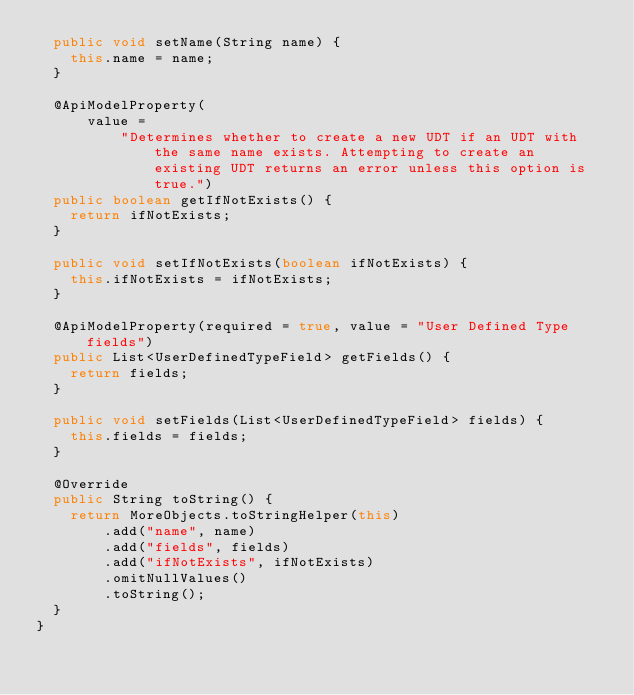<code> <loc_0><loc_0><loc_500><loc_500><_Java_>  public void setName(String name) {
    this.name = name;
  }

  @ApiModelProperty(
      value =
          "Determines whether to create a new UDT if an UDT with the same name exists. Attempting to create an existing UDT returns an error unless this option is true.")
  public boolean getIfNotExists() {
    return ifNotExists;
  }

  public void setIfNotExists(boolean ifNotExists) {
    this.ifNotExists = ifNotExists;
  }

  @ApiModelProperty(required = true, value = "User Defined Type fields")
  public List<UserDefinedTypeField> getFields() {
    return fields;
  }

  public void setFields(List<UserDefinedTypeField> fields) {
    this.fields = fields;
  }

  @Override
  public String toString() {
    return MoreObjects.toStringHelper(this)
        .add("name", name)
        .add("fields", fields)
        .add("ifNotExists", ifNotExists)
        .omitNullValues()
        .toString();
  }
}
</code> 